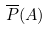<formula> <loc_0><loc_0><loc_500><loc_500>\overline { P } ( A )</formula> 